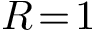Convert formula to latex. <formula><loc_0><loc_0><loc_500><loc_500>R \, = \, 1</formula> 